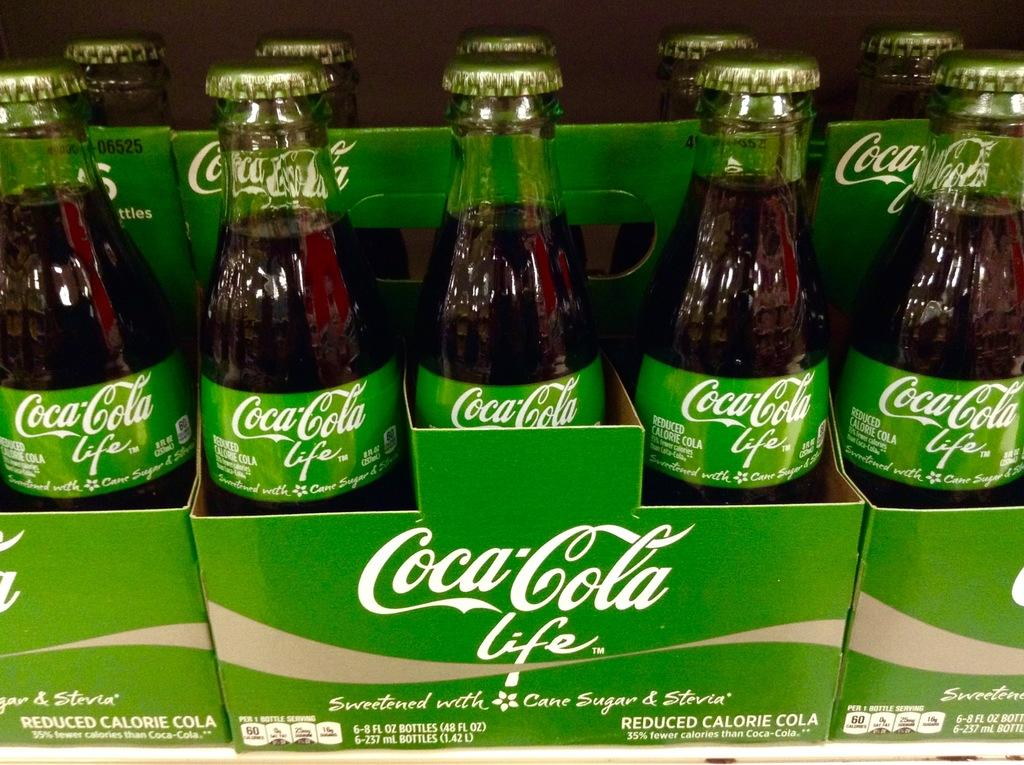Provide a one-sentence caption for the provided image. Packs of Coca-Cola life sit lined up next to each other. 